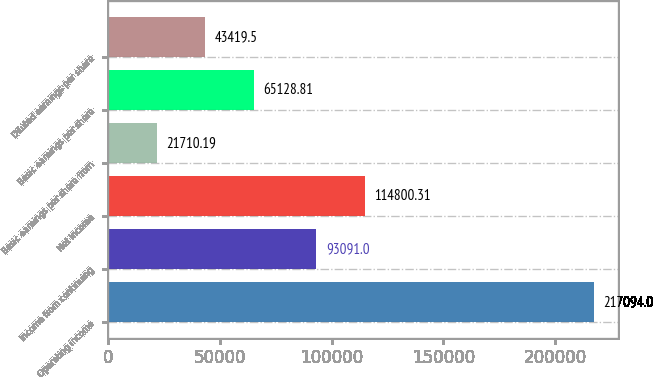Convert chart to OTSL. <chart><loc_0><loc_0><loc_500><loc_500><bar_chart><fcel>Operating income<fcel>Income from continuing<fcel>Net income<fcel>Basic earnings per share from<fcel>Basic earnings per share<fcel>Diluted earnings per share<nl><fcel>217094<fcel>93091<fcel>114800<fcel>21710.2<fcel>65128.8<fcel>43419.5<nl></chart> 